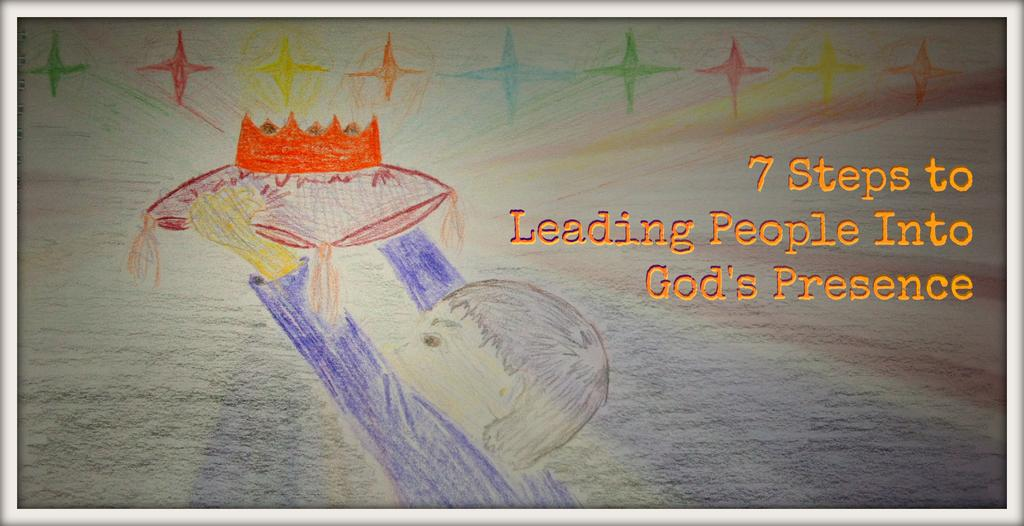What is depicted in the image? There is a colorful drawing in the image. What is the kid doing in the drawing? The kid is holding a crown in the drawing. What is the kid sitting on in the drawing? The kid is on a pillow in the drawing. Are there any words or letters in the image? Yes, there is text written on the image. What type of lunchroom is shown in the image? There is no lunchroom present in the image; it features a colorful drawing of a kid holding a crown and sitting on a pillow. What stage of development is the kid in the image? The image does not provide information about the kid's developmental stage; it only shows a drawing of a kid holding a crown and sitting on a pillow. 